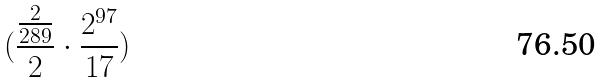Convert formula to latex. <formula><loc_0><loc_0><loc_500><loc_500>( \frac { \frac { 2 } { 2 8 9 } } { 2 } \cdot \frac { 2 ^ { 9 7 } } { 1 7 } )</formula> 